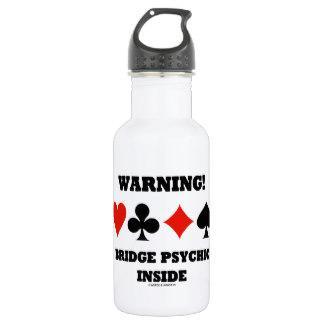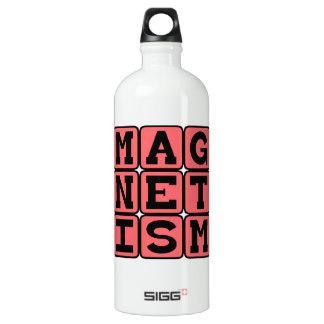The first image is the image on the left, the second image is the image on the right. Analyze the images presented: Is the assertion "One bottle has a round hole in the cap, and another bottle has an irregularly shaped hole in the cap." valid? Answer yes or no. Yes. The first image is the image on the left, the second image is the image on the right. For the images displayed, is the sentence "A water bottle is decorated with three rows of letters on squares that spell out a word." factually correct? Answer yes or no. Yes. 